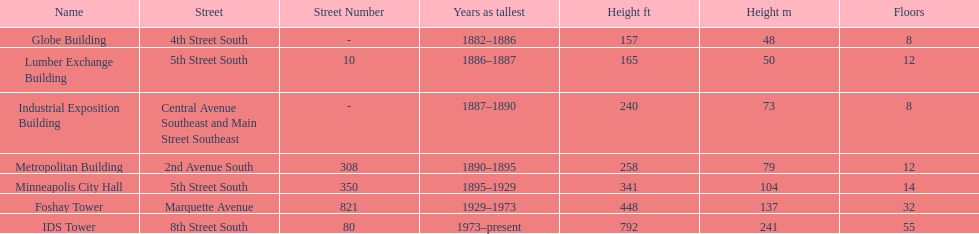Is the metropolitan building or the lumber exchange building taller? Metropolitan Building. 